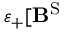<formula> <loc_0><loc_0><loc_500><loc_500>\varepsilon _ { + } [ B ^ { S }</formula> 